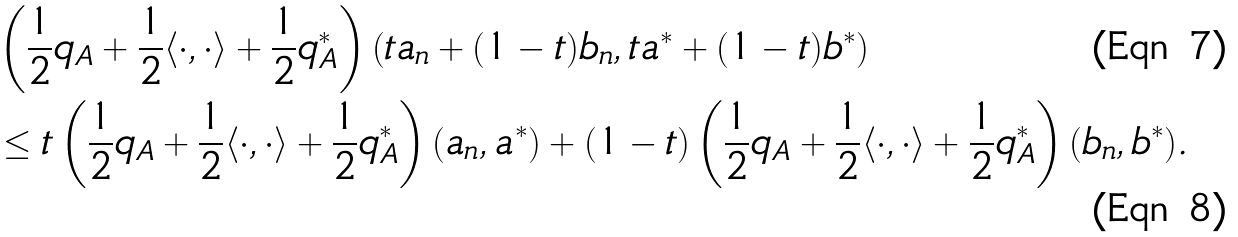Convert formula to latex. <formula><loc_0><loc_0><loc_500><loc_500>& \left ( \frac { 1 } { 2 } q _ { A } + \frac { 1 } { 2 } \langle \cdot , \cdot \rangle + \frac { 1 } { 2 } q ^ { * } _ { A } \right ) \left ( t a _ { n } + ( 1 - t ) b _ { n } , t a ^ { * } + ( 1 - t ) b ^ { * } \right ) \\ & \leq t \left ( \frac { 1 } { 2 } q _ { A } + \frac { 1 } { 2 } \langle \cdot , \cdot \rangle + \frac { 1 } { 2 } q ^ { * } _ { A } \right ) ( a _ { n } , a ^ { * } ) + ( 1 - t ) \left ( \frac { 1 } { 2 } q _ { A } + \frac { 1 } { 2 } \langle \cdot , \cdot \rangle + \frac { 1 } { 2 } q ^ { * } _ { A } \right ) ( b _ { n } , b ^ { * } ) .</formula> 